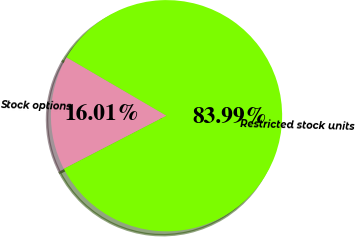<chart> <loc_0><loc_0><loc_500><loc_500><pie_chart><fcel>Stock options<fcel>Restricted stock units<nl><fcel>16.01%<fcel>83.99%<nl></chart> 